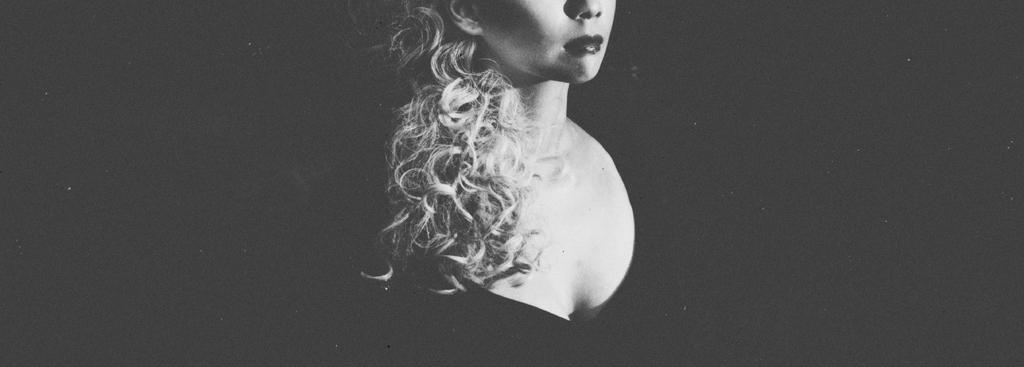What is the color scheme of the image? The image is black and white. Who is the main subject in the image? There is a lady in the middle of the image. How is the lady's hair styled in the image? The lady has her hair to the front. What color is the background of the image? The background of the image is black. What type of steel is used to construct the system in the image? There is no system or steel present in the image; it features a lady with her hair to the front against a black background. 